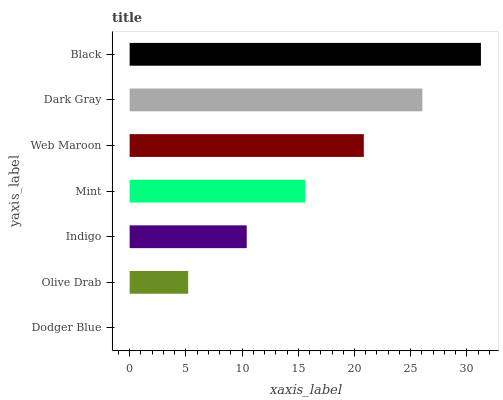Is Dodger Blue the minimum?
Answer yes or no. Yes. Is Black the maximum?
Answer yes or no. Yes. Is Olive Drab the minimum?
Answer yes or no. No. Is Olive Drab the maximum?
Answer yes or no. No. Is Olive Drab greater than Dodger Blue?
Answer yes or no. Yes. Is Dodger Blue less than Olive Drab?
Answer yes or no. Yes. Is Dodger Blue greater than Olive Drab?
Answer yes or no. No. Is Olive Drab less than Dodger Blue?
Answer yes or no. No. Is Mint the high median?
Answer yes or no. Yes. Is Mint the low median?
Answer yes or no. Yes. Is Dodger Blue the high median?
Answer yes or no. No. Is Dark Gray the low median?
Answer yes or no. No. 